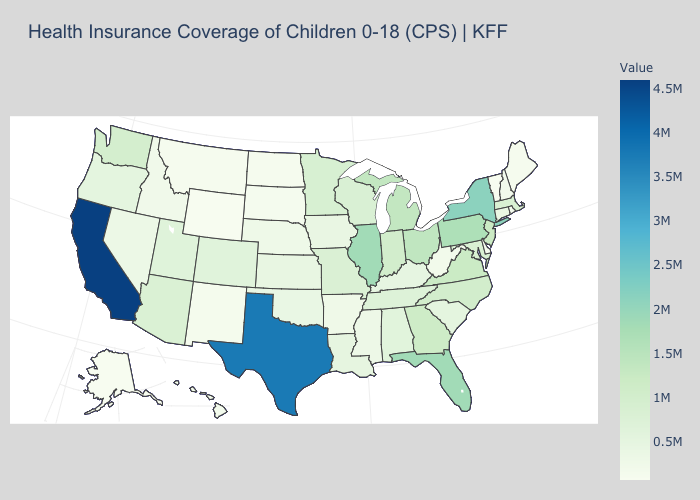Does the map have missing data?
Concise answer only. No. Does Vermont have the lowest value in the Northeast?
Give a very brief answer. Yes. Among the states that border Michigan , which have the lowest value?
Answer briefly. Wisconsin. Does Vermont have the lowest value in the USA?
Keep it brief. Yes. Among the states that border Ohio , does Pennsylvania have the highest value?
Quick response, please. Yes. 